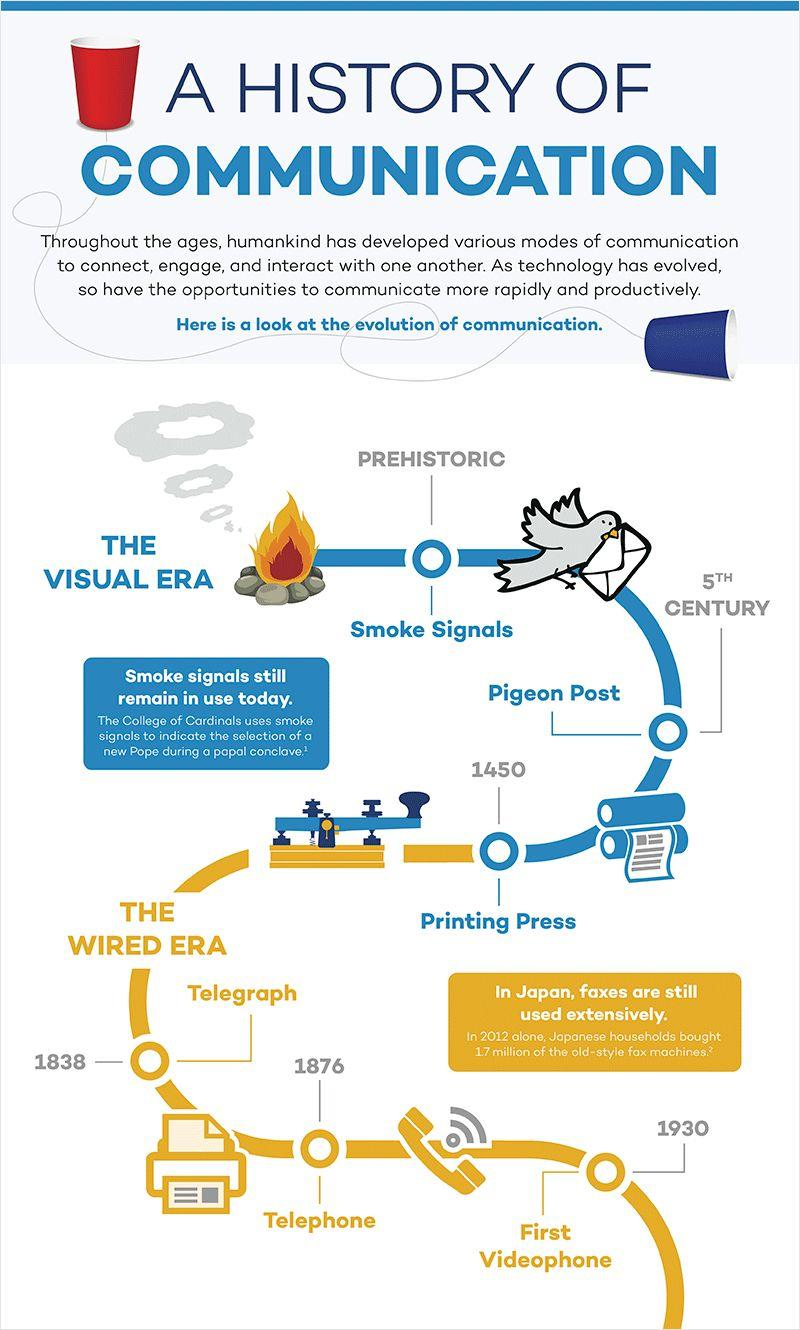Highlight a few significant elements in this photo. The invention of the telegraph occurred in 1838. The invention of the telephone, which took place in 1876, revolutionized the way people communicate and paved the way for modern telecommunications technology. 